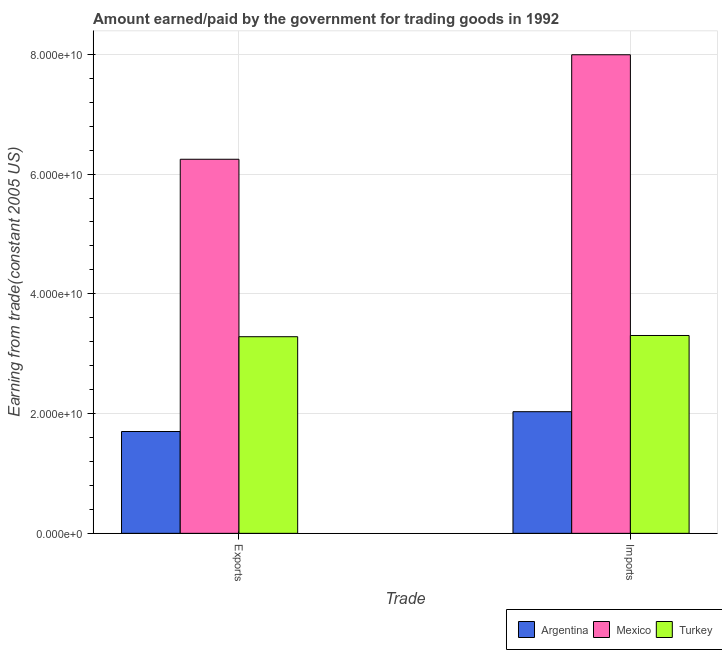How many different coloured bars are there?
Offer a terse response. 3. How many groups of bars are there?
Provide a short and direct response. 2. Are the number of bars per tick equal to the number of legend labels?
Offer a terse response. Yes. Are the number of bars on each tick of the X-axis equal?
Your answer should be compact. Yes. What is the label of the 1st group of bars from the left?
Give a very brief answer. Exports. What is the amount earned from exports in Turkey?
Ensure brevity in your answer.  3.28e+1. Across all countries, what is the maximum amount paid for imports?
Offer a very short reply. 7.99e+1. Across all countries, what is the minimum amount paid for imports?
Your response must be concise. 2.03e+1. In which country was the amount earned from exports maximum?
Make the answer very short. Mexico. In which country was the amount paid for imports minimum?
Make the answer very short. Argentina. What is the total amount paid for imports in the graph?
Give a very brief answer. 1.33e+11. What is the difference between the amount earned from exports in Turkey and that in Argentina?
Provide a succinct answer. 1.58e+1. What is the difference between the amount earned from exports in Argentina and the amount paid for imports in Mexico?
Your answer should be compact. -6.29e+1. What is the average amount paid for imports per country?
Your answer should be very brief. 4.44e+1. What is the difference between the amount paid for imports and amount earned from exports in Mexico?
Provide a succinct answer. 1.75e+1. In how many countries, is the amount paid for imports greater than 36000000000 US$?
Ensure brevity in your answer.  1. What is the ratio of the amount earned from exports in Mexico to that in Turkey?
Offer a very short reply. 1.9. Is the amount paid for imports in Argentina less than that in Turkey?
Ensure brevity in your answer.  Yes. In how many countries, is the amount paid for imports greater than the average amount paid for imports taken over all countries?
Your response must be concise. 1. What does the 3rd bar from the left in Exports represents?
Provide a short and direct response. Turkey. What does the 3rd bar from the right in Imports represents?
Provide a succinct answer. Argentina. How many countries are there in the graph?
Make the answer very short. 3. What is the difference between two consecutive major ticks on the Y-axis?
Keep it short and to the point. 2.00e+1. Are the values on the major ticks of Y-axis written in scientific E-notation?
Give a very brief answer. Yes. Does the graph contain any zero values?
Provide a succinct answer. No. Where does the legend appear in the graph?
Offer a very short reply. Bottom right. How many legend labels are there?
Give a very brief answer. 3. What is the title of the graph?
Provide a succinct answer. Amount earned/paid by the government for trading goods in 1992. What is the label or title of the X-axis?
Provide a succinct answer. Trade. What is the label or title of the Y-axis?
Offer a terse response. Earning from trade(constant 2005 US). What is the Earning from trade(constant 2005 US) in Argentina in Exports?
Your response must be concise. 1.70e+1. What is the Earning from trade(constant 2005 US) of Mexico in Exports?
Offer a terse response. 6.25e+1. What is the Earning from trade(constant 2005 US) of Turkey in Exports?
Offer a terse response. 3.28e+1. What is the Earning from trade(constant 2005 US) in Argentina in Imports?
Offer a very short reply. 2.03e+1. What is the Earning from trade(constant 2005 US) of Mexico in Imports?
Your answer should be compact. 7.99e+1. What is the Earning from trade(constant 2005 US) of Turkey in Imports?
Your response must be concise. 3.30e+1. Across all Trade, what is the maximum Earning from trade(constant 2005 US) in Argentina?
Give a very brief answer. 2.03e+1. Across all Trade, what is the maximum Earning from trade(constant 2005 US) of Mexico?
Keep it short and to the point. 7.99e+1. Across all Trade, what is the maximum Earning from trade(constant 2005 US) in Turkey?
Ensure brevity in your answer.  3.30e+1. Across all Trade, what is the minimum Earning from trade(constant 2005 US) in Argentina?
Your answer should be compact. 1.70e+1. Across all Trade, what is the minimum Earning from trade(constant 2005 US) in Mexico?
Make the answer very short. 6.25e+1. Across all Trade, what is the minimum Earning from trade(constant 2005 US) of Turkey?
Your response must be concise. 3.28e+1. What is the total Earning from trade(constant 2005 US) of Argentina in the graph?
Keep it short and to the point. 3.73e+1. What is the total Earning from trade(constant 2005 US) in Mexico in the graph?
Your response must be concise. 1.42e+11. What is the total Earning from trade(constant 2005 US) of Turkey in the graph?
Give a very brief answer. 6.59e+1. What is the difference between the Earning from trade(constant 2005 US) in Argentina in Exports and that in Imports?
Give a very brief answer. -3.31e+09. What is the difference between the Earning from trade(constant 2005 US) of Mexico in Exports and that in Imports?
Make the answer very short. -1.75e+1. What is the difference between the Earning from trade(constant 2005 US) in Turkey in Exports and that in Imports?
Ensure brevity in your answer.  -2.04e+08. What is the difference between the Earning from trade(constant 2005 US) of Argentina in Exports and the Earning from trade(constant 2005 US) of Mexico in Imports?
Your answer should be compact. -6.29e+1. What is the difference between the Earning from trade(constant 2005 US) of Argentina in Exports and the Earning from trade(constant 2005 US) of Turkey in Imports?
Keep it short and to the point. -1.60e+1. What is the difference between the Earning from trade(constant 2005 US) of Mexico in Exports and the Earning from trade(constant 2005 US) of Turkey in Imports?
Your answer should be very brief. 2.94e+1. What is the average Earning from trade(constant 2005 US) in Argentina per Trade?
Offer a terse response. 1.87e+1. What is the average Earning from trade(constant 2005 US) of Mexico per Trade?
Provide a succinct answer. 7.12e+1. What is the average Earning from trade(constant 2005 US) of Turkey per Trade?
Your response must be concise. 3.29e+1. What is the difference between the Earning from trade(constant 2005 US) of Argentina and Earning from trade(constant 2005 US) of Mexico in Exports?
Offer a terse response. -4.55e+1. What is the difference between the Earning from trade(constant 2005 US) of Argentina and Earning from trade(constant 2005 US) of Turkey in Exports?
Give a very brief answer. -1.58e+1. What is the difference between the Earning from trade(constant 2005 US) in Mexico and Earning from trade(constant 2005 US) in Turkey in Exports?
Your answer should be compact. 2.96e+1. What is the difference between the Earning from trade(constant 2005 US) of Argentina and Earning from trade(constant 2005 US) of Mexico in Imports?
Provide a short and direct response. -5.96e+1. What is the difference between the Earning from trade(constant 2005 US) of Argentina and Earning from trade(constant 2005 US) of Turkey in Imports?
Offer a very short reply. -1.27e+1. What is the difference between the Earning from trade(constant 2005 US) in Mexico and Earning from trade(constant 2005 US) in Turkey in Imports?
Your response must be concise. 4.69e+1. What is the ratio of the Earning from trade(constant 2005 US) in Argentina in Exports to that in Imports?
Ensure brevity in your answer.  0.84. What is the ratio of the Earning from trade(constant 2005 US) of Mexico in Exports to that in Imports?
Make the answer very short. 0.78. What is the difference between the highest and the second highest Earning from trade(constant 2005 US) of Argentina?
Provide a succinct answer. 3.31e+09. What is the difference between the highest and the second highest Earning from trade(constant 2005 US) of Mexico?
Give a very brief answer. 1.75e+1. What is the difference between the highest and the second highest Earning from trade(constant 2005 US) in Turkey?
Your response must be concise. 2.04e+08. What is the difference between the highest and the lowest Earning from trade(constant 2005 US) of Argentina?
Offer a terse response. 3.31e+09. What is the difference between the highest and the lowest Earning from trade(constant 2005 US) in Mexico?
Offer a very short reply. 1.75e+1. What is the difference between the highest and the lowest Earning from trade(constant 2005 US) of Turkey?
Give a very brief answer. 2.04e+08. 